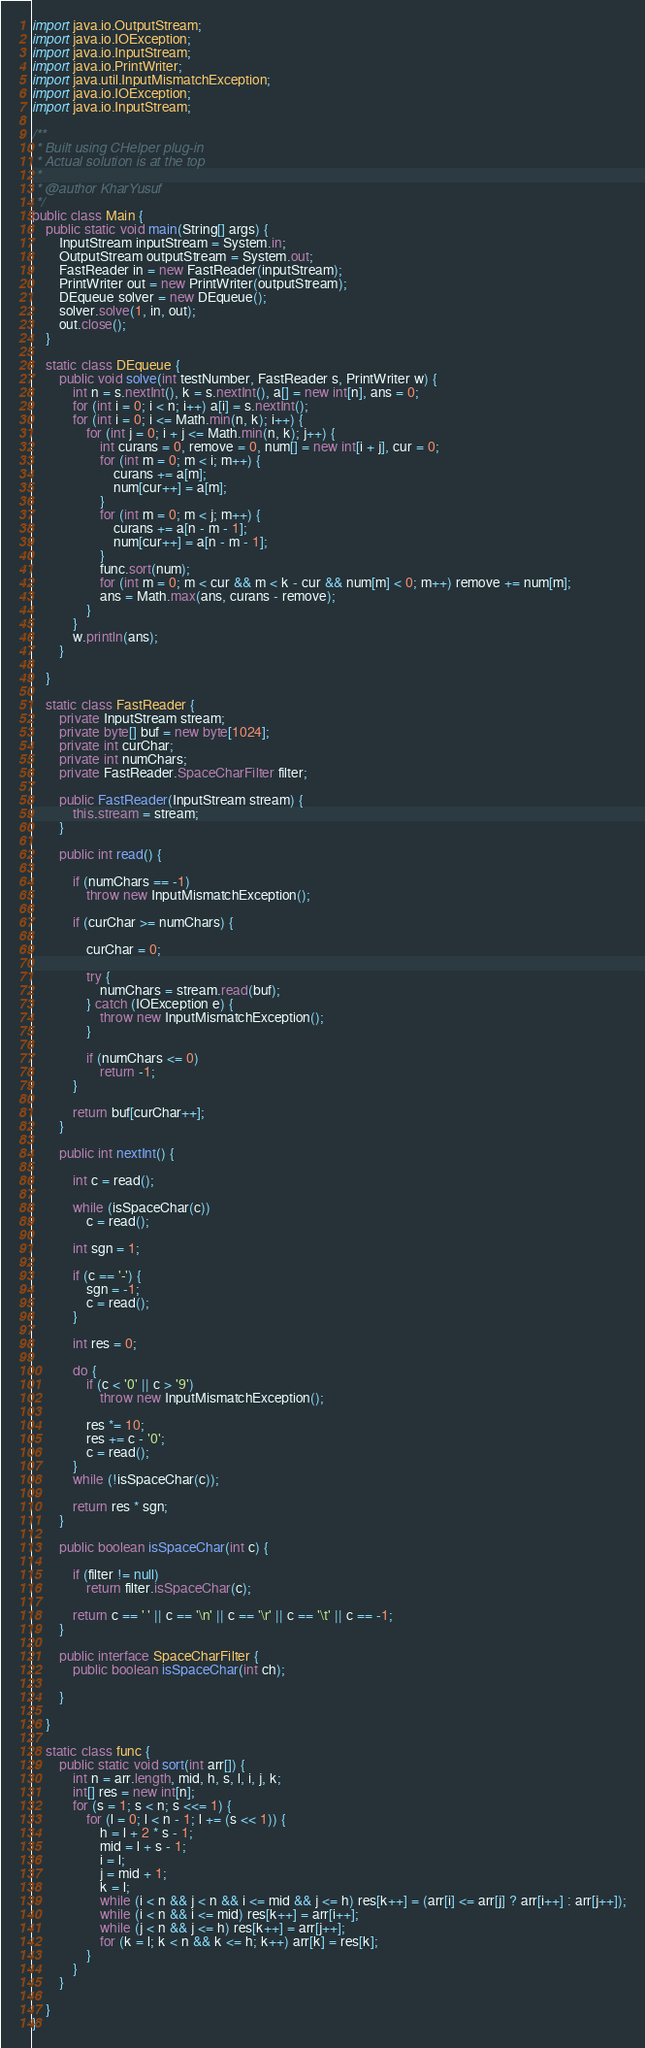Convert code to text. <code><loc_0><loc_0><loc_500><loc_500><_Java_>import java.io.OutputStream;
import java.io.IOException;
import java.io.InputStream;
import java.io.PrintWriter;
import java.util.InputMismatchException;
import java.io.IOException;
import java.io.InputStream;

/**
 * Built using CHelper plug-in
 * Actual solution is at the top
 *
 * @author KharYusuf
 */
public class Main {
    public static void main(String[] args) {
        InputStream inputStream = System.in;
        OutputStream outputStream = System.out;
        FastReader in = new FastReader(inputStream);
        PrintWriter out = new PrintWriter(outputStream);
        DEqueue solver = new DEqueue();
        solver.solve(1, in, out);
        out.close();
    }

    static class DEqueue {
        public void solve(int testNumber, FastReader s, PrintWriter w) {
            int n = s.nextInt(), k = s.nextInt(), a[] = new int[n], ans = 0;
            for (int i = 0; i < n; i++) a[i] = s.nextInt();
            for (int i = 0; i <= Math.min(n, k); i++) {
                for (int j = 0; i + j <= Math.min(n, k); j++) {
                    int curans = 0, remove = 0, num[] = new int[i + j], cur = 0;
                    for (int m = 0; m < i; m++) {
                        curans += a[m];
                        num[cur++] = a[m];
                    }
                    for (int m = 0; m < j; m++) {
                        curans += a[n - m - 1];
                        num[cur++] = a[n - m - 1];
                    }
                    func.sort(num);
                    for (int m = 0; m < cur && m < k - cur && num[m] < 0; m++) remove += num[m];
                    ans = Math.max(ans, curans - remove);
                }
            }
            w.println(ans);
        }

    }

    static class FastReader {
        private InputStream stream;
        private byte[] buf = new byte[1024];
        private int curChar;
        private int numChars;
        private FastReader.SpaceCharFilter filter;

        public FastReader(InputStream stream) {
            this.stream = stream;
        }

        public int read() {

            if (numChars == -1)
                throw new InputMismatchException();

            if (curChar >= numChars) {

                curChar = 0;

                try {
                    numChars = stream.read(buf);
                } catch (IOException e) {
                    throw new InputMismatchException();
                }

                if (numChars <= 0)
                    return -1;
            }

            return buf[curChar++];
        }

        public int nextInt() {

            int c = read();

            while (isSpaceChar(c))
                c = read();

            int sgn = 1;

            if (c == '-') {
                sgn = -1;
                c = read();
            }

            int res = 0;

            do {
                if (c < '0' || c > '9')
                    throw new InputMismatchException();

                res *= 10;
                res += c - '0';
                c = read();
            }
            while (!isSpaceChar(c));

            return res * sgn;
        }

        public boolean isSpaceChar(int c) {

            if (filter != null)
                return filter.isSpaceChar(c);

            return c == ' ' || c == '\n' || c == '\r' || c == '\t' || c == -1;
        }

        public interface SpaceCharFilter {
            public boolean isSpaceChar(int ch);

        }

    }

    static class func {
        public static void sort(int arr[]) {
            int n = arr.length, mid, h, s, l, i, j, k;
            int[] res = new int[n];
            for (s = 1; s < n; s <<= 1) {
                for (l = 0; l < n - 1; l += (s << 1)) {
                    h = l + 2 * s - 1;
                    mid = l + s - 1;
                    i = l;
                    j = mid + 1;
                    k = l;
                    while (i < n && j < n && i <= mid && j <= h) res[k++] = (arr[i] <= arr[j] ? arr[i++] : arr[j++]);
                    while (i < n && i <= mid) res[k++] = arr[i++];
                    while (j < n && j <= h) res[k++] = arr[j++];
                    for (k = l; k < n && k <= h; k++) arr[k] = res[k];
                }
            }
        }

    }
}

</code> 